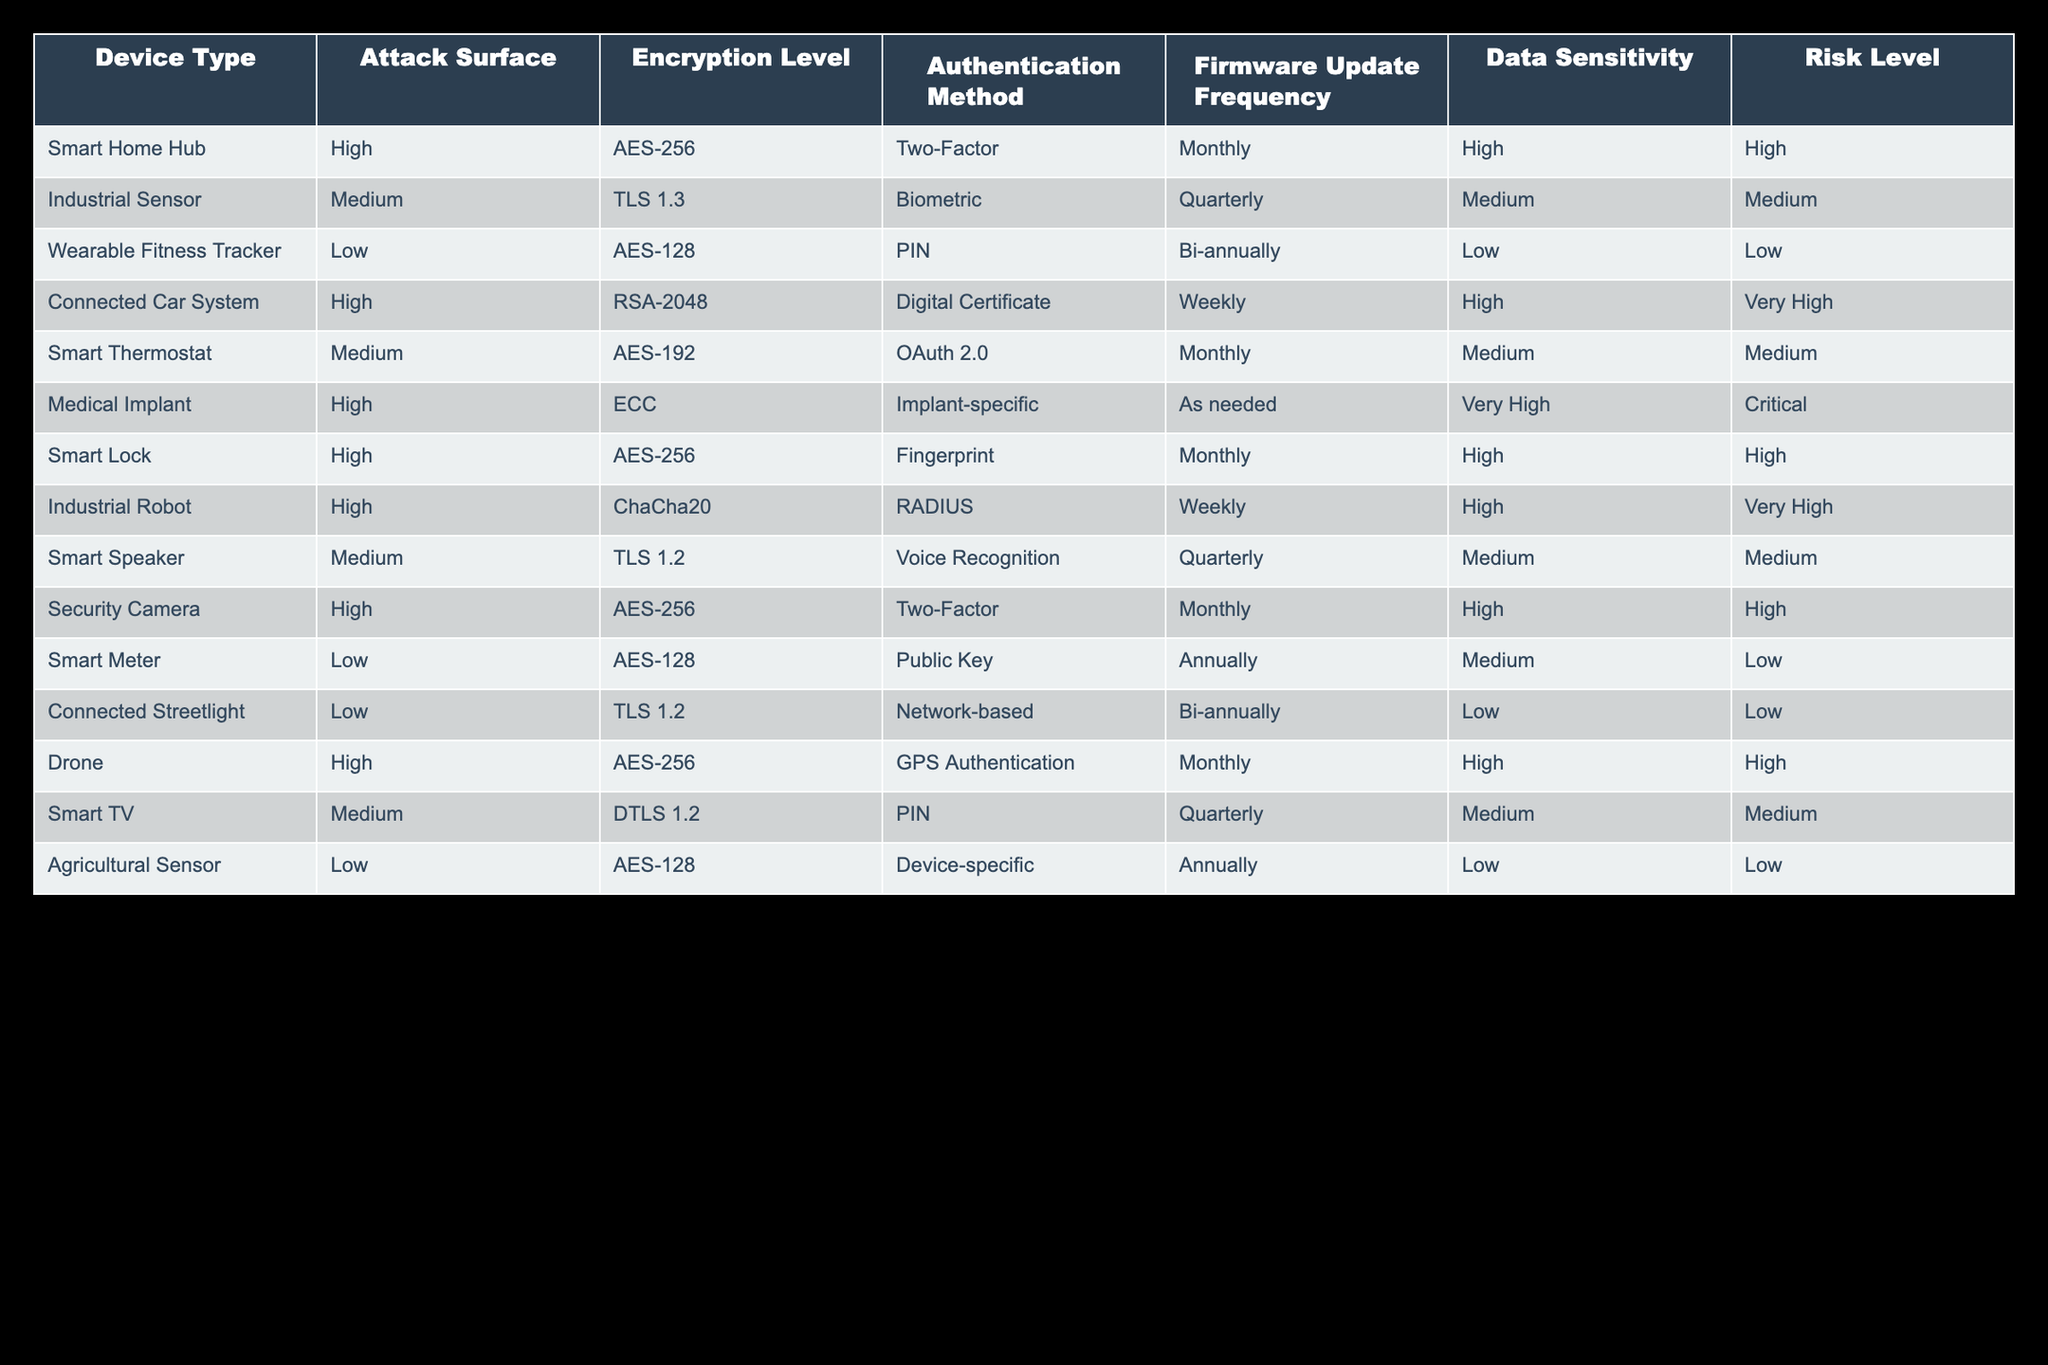What is the highest risk level among the IoT devices? The table lists different risk levels, and upon reviewing the entries, the "Connected Car System," "Industrial Robot," and "Medical Implant" each have a "Very High" risk level. However, "Medical Implant" is marked as "Critical," which is the highest risk classification.
Answer: Critical Which device has the lowest encryption level? The encryption levels are mentioned for each device. Upon examining the devices, the "Wearable Fitness Tracker," "Smart Meter," "Connected Streetlight," and "Agricultural Sensor" all utilize "AES-128," which is the lowest encryption level listed.
Answer: AES-128 How many devices have a high attack surface and a monthly firmware update frequency? We need to filter the table for devices with a "High" attack surface and "Monthly" firmware update frequency. The "Smart Home Hub," "Smart Lock," "Security Camera," and "Drone" qualify, totaling four devices.
Answer: 4 Is there any device that uses biometric authentication and has a medium risk level? The "Industrial Sensor" is the only device that employs biometric authentication and is categorized as having a medium risk level. The other biometric authentication methods are associated with high risk devices instead.
Answer: Yes What is the average data sensitivity level for devices with a low encryption level? We identify "Wearable Fitness Tracker," "Smart Meter," "Connected Streetlight," and "Agricultural Sensor" with a low encryption level of "AES-128." The data sensitivity levels are "Low" for all, thus averaging to "Low" as there are no higher sensitivity levels present.
Answer: Low What is the relationship between encryption level and risk level in the context of high attack surface devices? High attack surface devices are examined, specifically "Connected Car System," "Industrial Robot," "Smart Home Hub," "Smart Lock," "Security Camera," and "Drone." Encryption levels varied here, but key insights include that all except the "Security Camera" and "Drone" have risks categorized as "High" or "Very High." This indicates that stronger encryption correlates with higher risk levels for critical devices.
Answer: Stronger encryption correlates with higher risks Which device has the highest frequency of firmware updates among those rated as "Very High" risk? From the high-risk devices question, both the "Connected Car System" and "Industrial Robot" update firmware weekly. We analyze firmware frequency along with their respective risk levels and find both devices were rated "Very High." Thus, the answer reveals that they share the highest frequency.
Answer: Connected Car System and Industrial Robot Are there any devices listed with a risk level classified as "Low"? Referring to the table, yes, "Wearable Fitness Tracker," "Smart Meter," "Connected Streetlight," and "Agricultural Sensor" are all considered to have a "Low" risk level.
Answer: Yes 